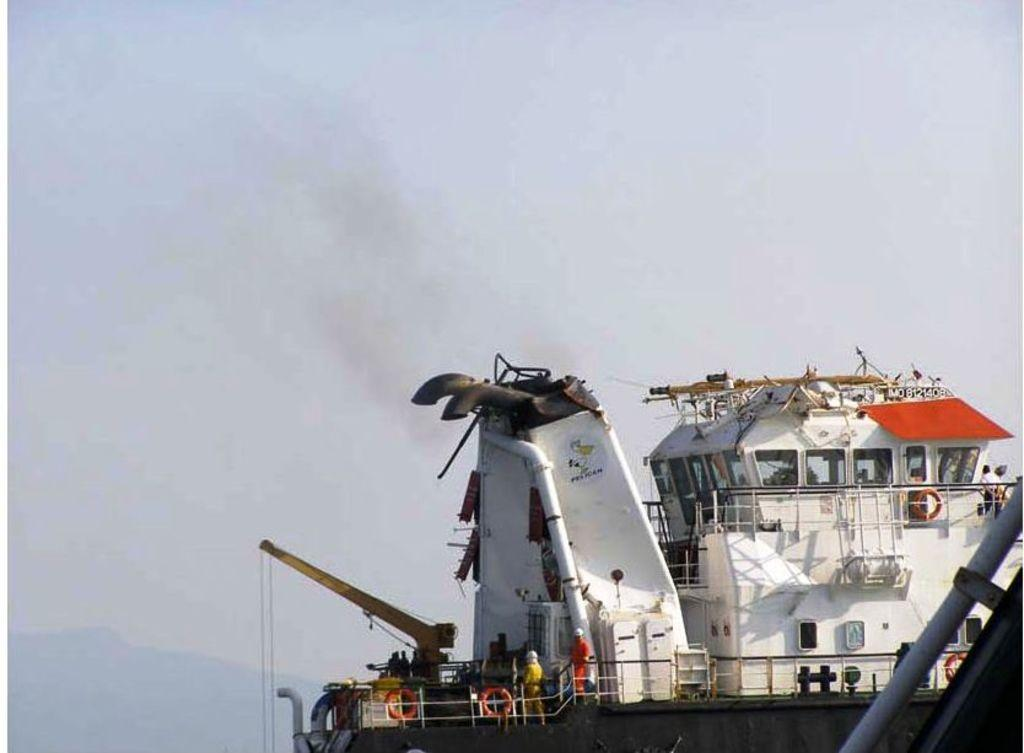What is the main subject of the image? There is a big ship in the image. Are there any people on the ship? Yes, there are people standing on the ship. What else can be seen on the ship besides the people? There are other objects visible on the ship. Where is the drawer located on the ship? There is no drawer present on the ship in the image. 